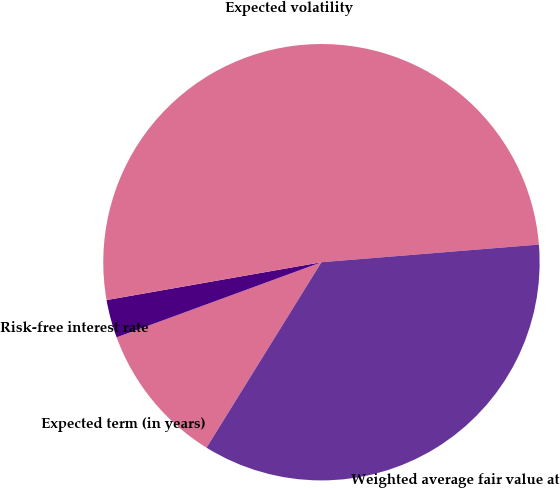Convert chart to OTSL. <chart><loc_0><loc_0><loc_500><loc_500><pie_chart><fcel>Expected term (in years)<fcel>Risk-free interest rate<fcel>Expected volatility<fcel>Weighted average fair value at<nl><fcel>10.58%<fcel>2.82%<fcel>51.49%<fcel>35.12%<nl></chart> 